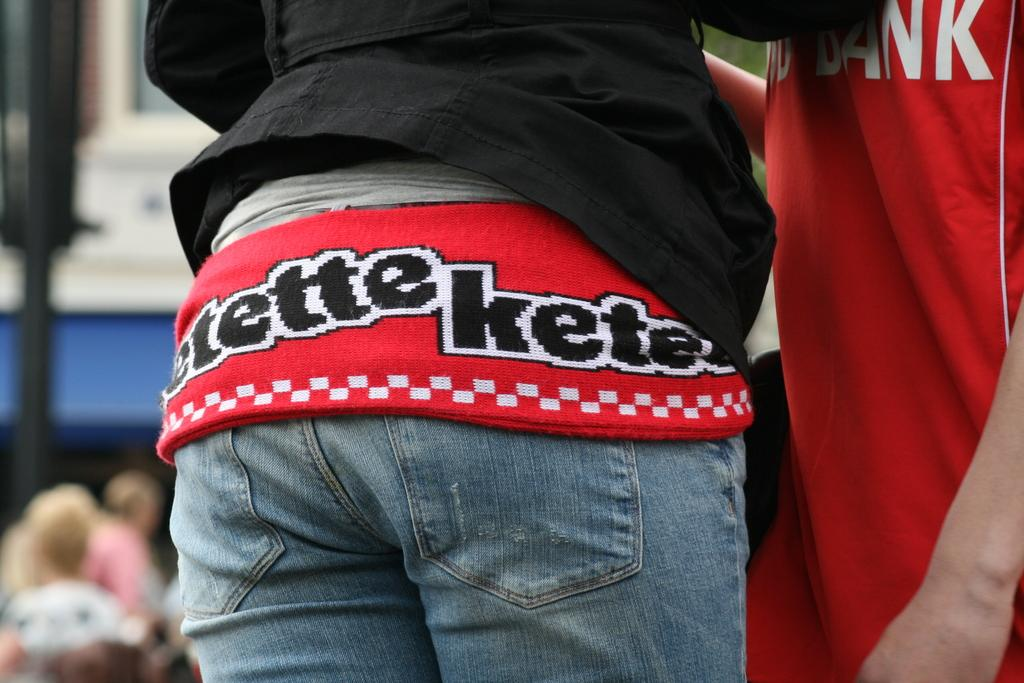Who or what is present in the image? There are people in the image. What can be observed about the people's clothing? The people are wearing different color dresses. Can you describe the background of the image? The background of the image is blurred. What causes the people to pull the rope in the image? There is no rope present in the image, so it cannot be determined what might cause the people to pull it. 